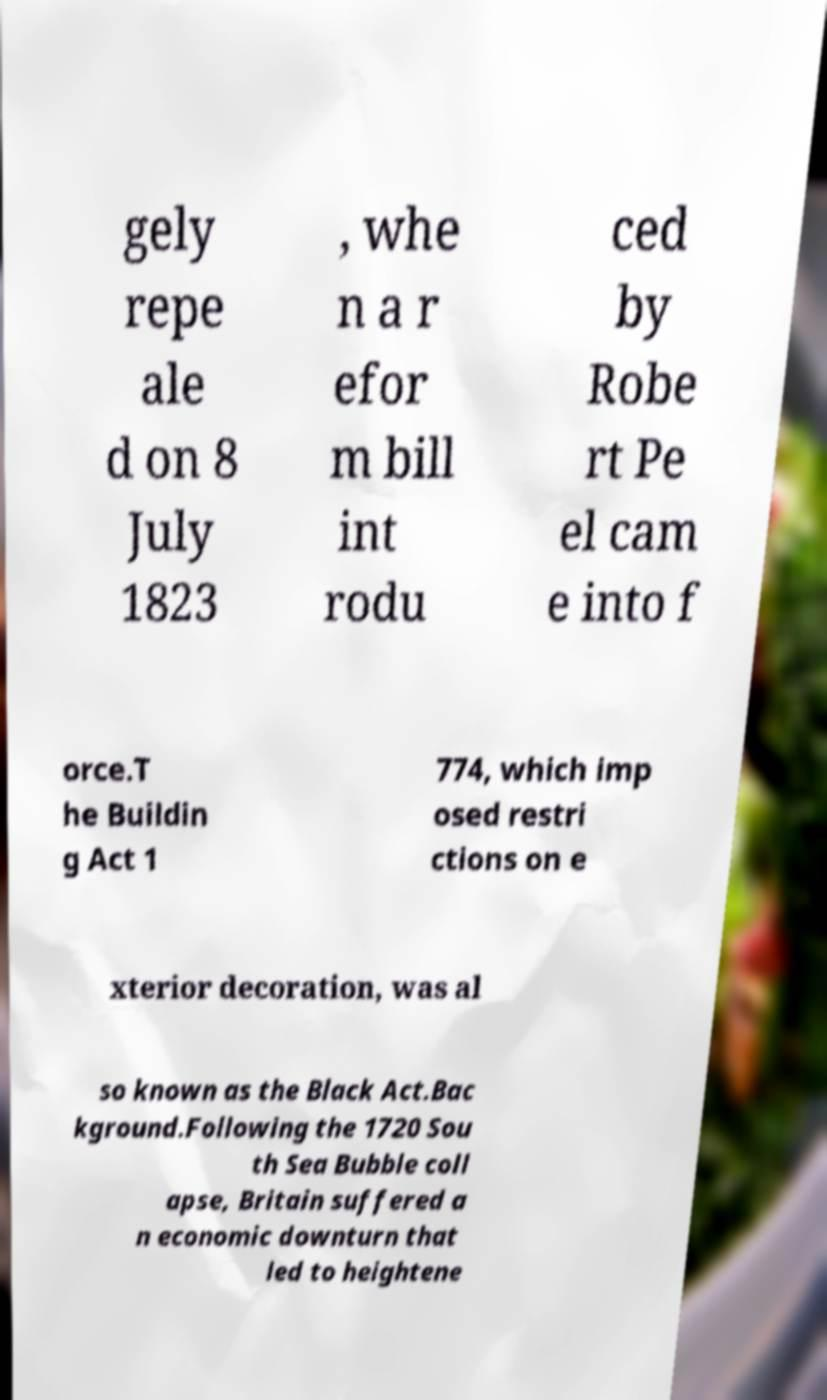Can you read and provide the text displayed in the image?This photo seems to have some interesting text. Can you extract and type it out for me? gely repe ale d on 8 July 1823 , whe n a r efor m bill int rodu ced by Robe rt Pe el cam e into f orce.T he Buildin g Act 1 774, which imp osed restri ctions on e xterior decoration, was al so known as the Black Act.Bac kground.Following the 1720 Sou th Sea Bubble coll apse, Britain suffered a n economic downturn that led to heightene 